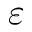<formula> <loc_0><loc_0><loc_500><loc_500>\varepsilon</formula> 